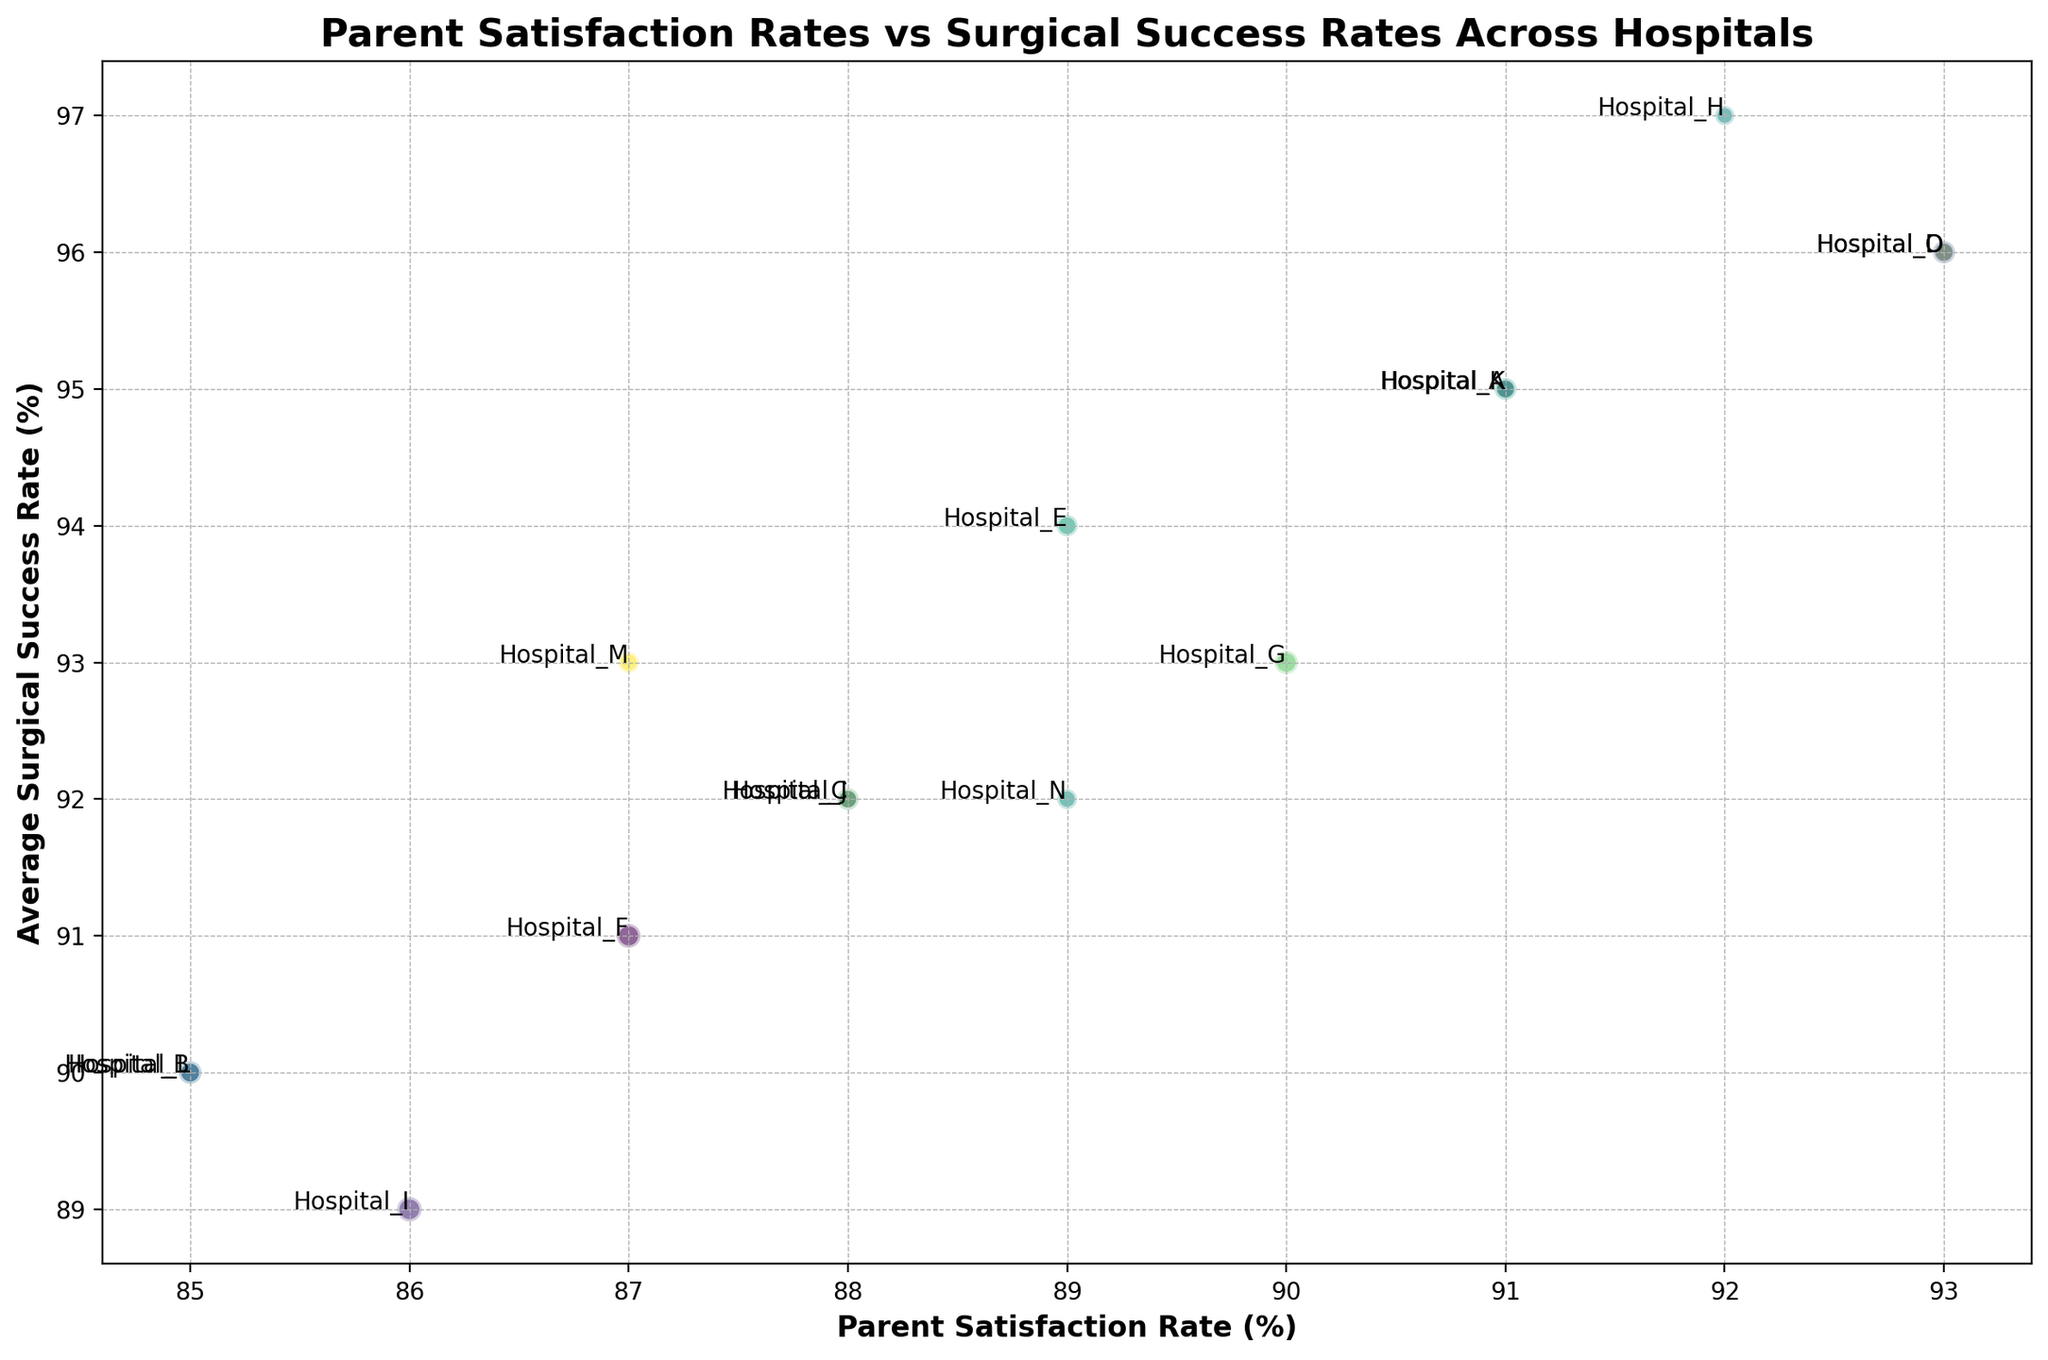What's the highest parent satisfaction rate among all hospitals? Look for the data point that has the highest value on the x-axis representing Parent Satisfaction Rate.
Answer: 93% Which hospital has the lowest surgical success rate? Look for the bubble at the lowest point on the y-axis representing Average Surgical Success Rate.
Answer: Hospital I Are there any hospitals with both high parent satisfaction rates and high surgical success rates? Look for data points in the upper right quadrant of the plot where both x and y values are high.
Answer: Yes, Hospitals D, H, and O How many surgeries were performed by the hospital with the highest satisfaction rate? Identify the bubble for the hospital with the highest parent satisfaction rate and observe its size, reference the data table for the exact number if necessary.
Answer: 175 Which hospitals have a parent satisfaction rate greater than 90%? Look for bubbles positioned to the right of the 90% mark on the x-axis.
Answer: Hospitals A, D, H, K, and O What is the difference in parent satisfaction rates between the hospital with the highest satisfaction and the one with the lowest satisfaction? Find the highest parent satisfaction rate (93%) and the lowest (85%) and subtract the latter from the former.
Answer: 8% Which hospitals are colored similarly and have similar satisfaction rates and surgical success rates? Look for bubbles with the same or similar colors located near each other in the figure.
Answer: Hospitals B and L What's the relationship between the number of surgeries and bubble size on the plot? Larger bubble size corresponds to a higher number of surgeries performed by the hospital.
Answer: Direct relationship Which hospital has the largest bubble size? Identify the bubble with the largest area on the plot, which denotes the highest number of surgeries.
Answer: Hospital I Is there any hospital with both a parent satisfaction rate below 90% and a surgical success rate above 95%? Look for bubbles in the lower right side of the plot where x < 90% and y > 95%.
Answer: No 